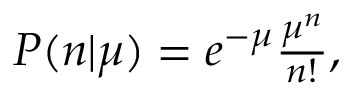<formula> <loc_0><loc_0><loc_500><loc_500>\begin{array} { r } { P ( n | \mu ) = e ^ { - \mu } \frac { \mu ^ { n } } { n ! } , } \end{array}</formula> 